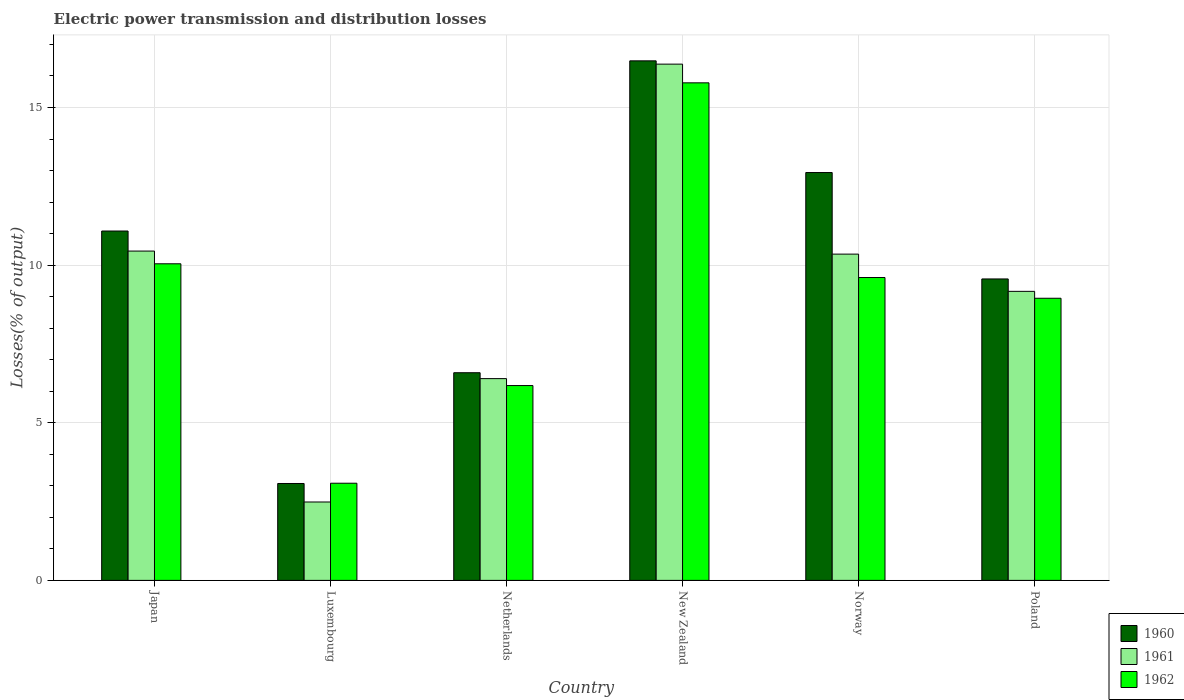How many different coloured bars are there?
Your answer should be compact. 3. How many groups of bars are there?
Your answer should be very brief. 6. Are the number of bars per tick equal to the number of legend labels?
Offer a very short reply. Yes. Are the number of bars on each tick of the X-axis equal?
Offer a terse response. Yes. How many bars are there on the 2nd tick from the left?
Provide a short and direct response. 3. How many bars are there on the 5th tick from the right?
Give a very brief answer. 3. What is the electric power transmission and distribution losses in 1962 in Norway?
Provide a short and direct response. 9.61. Across all countries, what is the maximum electric power transmission and distribution losses in 1960?
Offer a very short reply. 16.48. Across all countries, what is the minimum electric power transmission and distribution losses in 1962?
Give a very brief answer. 3.08. In which country was the electric power transmission and distribution losses in 1962 maximum?
Give a very brief answer. New Zealand. In which country was the electric power transmission and distribution losses in 1962 minimum?
Provide a succinct answer. Luxembourg. What is the total electric power transmission and distribution losses in 1960 in the graph?
Make the answer very short. 59.72. What is the difference between the electric power transmission and distribution losses in 1960 in New Zealand and that in Norway?
Keep it short and to the point. 3.54. What is the difference between the electric power transmission and distribution losses in 1960 in New Zealand and the electric power transmission and distribution losses in 1962 in Norway?
Provide a short and direct response. 6.87. What is the average electric power transmission and distribution losses in 1960 per country?
Make the answer very short. 9.95. What is the difference between the electric power transmission and distribution losses of/in 1960 and electric power transmission and distribution losses of/in 1961 in Netherlands?
Your answer should be very brief. 0.19. What is the ratio of the electric power transmission and distribution losses in 1962 in Japan to that in Poland?
Make the answer very short. 1.12. Is the difference between the electric power transmission and distribution losses in 1960 in Luxembourg and Netherlands greater than the difference between the electric power transmission and distribution losses in 1961 in Luxembourg and Netherlands?
Offer a terse response. Yes. What is the difference between the highest and the second highest electric power transmission and distribution losses in 1961?
Ensure brevity in your answer.  5.93. What is the difference between the highest and the lowest electric power transmission and distribution losses in 1962?
Your answer should be very brief. 12.7. Is the sum of the electric power transmission and distribution losses in 1962 in Japan and Luxembourg greater than the maximum electric power transmission and distribution losses in 1960 across all countries?
Provide a short and direct response. No. What does the 1st bar from the right in Netherlands represents?
Your answer should be compact. 1962. Is it the case that in every country, the sum of the electric power transmission and distribution losses in 1962 and electric power transmission and distribution losses in 1961 is greater than the electric power transmission and distribution losses in 1960?
Provide a succinct answer. Yes. How many bars are there?
Offer a very short reply. 18. How many countries are there in the graph?
Your answer should be very brief. 6. Are the values on the major ticks of Y-axis written in scientific E-notation?
Offer a very short reply. No. Does the graph contain any zero values?
Your answer should be very brief. No. Does the graph contain grids?
Give a very brief answer. Yes. How are the legend labels stacked?
Your response must be concise. Vertical. What is the title of the graph?
Make the answer very short. Electric power transmission and distribution losses. Does "2000" appear as one of the legend labels in the graph?
Provide a succinct answer. No. What is the label or title of the Y-axis?
Make the answer very short. Losses(% of output). What is the Losses(% of output) in 1960 in Japan?
Keep it short and to the point. 11.08. What is the Losses(% of output) in 1961 in Japan?
Make the answer very short. 10.45. What is the Losses(% of output) of 1962 in Japan?
Your response must be concise. 10.04. What is the Losses(% of output) of 1960 in Luxembourg?
Give a very brief answer. 3.07. What is the Losses(% of output) of 1961 in Luxembourg?
Your answer should be compact. 2.49. What is the Losses(% of output) in 1962 in Luxembourg?
Make the answer very short. 3.08. What is the Losses(% of output) in 1960 in Netherlands?
Ensure brevity in your answer.  6.59. What is the Losses(% of output) of 1961 in Netherlands?
Offer a terse response. 6.4. What is the Losses(% of output) of 1962 in Netherlands?
Offer a terse response. 6.18. What is the Losses(% of output) of 1960 in New Zealand?
Your response must be concise. 16.48. What is the Losses(% of output) of 1961 in New Zealand?
Your response must be concise. 16.38. What is the Losses(% of output) in 1962 in New Zealand?
Offer a very short reply. 15.78. What is the Losses(% of output) in 1960 in Norway?
Your answer should be compact. 12.94. What is the Losses(% of output) of 1961 in Norway?
Make the answer very short. 10.35. What is the Losses(% of output) in 1962 in Norway?
Make the answer very short. 9.61. What is the Losses(% of output) in 1960 in Poland?
Offer a terse response. 9.56. What is the Losses(% of output) of 1961 in Poland?
Your response must be concise. 9.17. What is the Losses(% of output) in 1962 in Poland?
Your answer should be very brief. 8.95. Across all countries, what is the maximum Losses(% of output) of 1960?
Provide a succinct answer. 16.48. Across all countries, what is the maximum Losses(% of output) of 1961?
Offer a very short reply. 16.38. Across all countries, what is the maximum Losses(% of output) in 1962?
Your answer should be compact. 15.78. Across all countries, what is the minimum Losses(% of output) in 1960?
Offer a very short reply. 3.07. Across all countries, what is the minimum Losses(% of output) of 1961?
Your answer should be very brief. 2.49. Across all countries, what is the minimum Losses(% of output) of 1962?
Your answer should be very brief. 3.08. What is the total Losses(% of output) of 1960 in the graph?
Your answer should be very brief. 59.72. What is the total Losses(% of output) in 1961 in the graph?
Your answer should be very brief. 55.23. What is the total Losses(% of output) in 1962 in the graph?
Your response must be concise. 53.65. What is the difference between the Losses(% of output) in 1960 in Japan and that in Luxembourg?
Ensure brevity in your answer.  8.01. What is the difference between the Losses(% of output) of 1961 in Japan and that in Luxembourg?
Your answer should be compact. 7.96. What is the difference between the Losses(% of output) of 1962 in Japan and that in Luxembourg?
Ensure brevity in your answer.  6.96. What is the difference between the Losses(% of output) of 1960 in Japan and that in Netherlands?
Ensure brevity in your answer.  4.49. What is the difference between the Losses(% of output) of 1961 in Japan and that in Netherlands?
Your response must be concise. 4.05. What is the difference between the Losses(% of output) of 1962 in Japan and that in Netherlands?
Your response must be concise. 3.86. What is the difference between the Losses(% of output) of 1960 in Japan and that in New Zealand?
Give a very brief answer. -5.4. What is the difference between the Losses(% of output) of 1961 in Japan and that in New Zealand?
Provide a short and direct response. -5.93. What is the difference between the Losses(% of output) of 1962 in Japan and that in New Zealand?
Offer a very short reply. -5.74. What is the difference between the Losses(% of output) in 1960 in Japan and that in Norway?
Provide a short and direct response. -1.85. What is the difference between the Losses(% of output) in 1961 in Japan and that in Norway?
Your answer should be very brief. 0.1. What is the difference between the Losses(% of output) of 1962 in Japan and that in Norway?
Your answer should be compact. 0.44. What is the difference between the Losses(% of output) of 1960 in Japan and that in Poland?
Offer a very short reply. 1.52. What is the difference between the Losses(% of output) of 1961 in Japan and that in Poland?
Ensure brevity in your answer.  1.28. What is the difference between the Losses(% of output) in 1962 in Japan and that in Poland?
Your answer should be very brief. 1.09. What is the difference between the Losses(% of output) of 1960 in Luxembourg and that in Netherlands?
Provide a succinct answer. -3.51. What is the difference between the Losses(% of output) in 1961 in Luxembourg and that in Netherlands?
Your response must be concise. -3.91. What is the difference between the Losses(% of output) of 1962 in Luxembourg and that in Netherlands?
Offer a very short reply. -3.1. What is the difference between the Losses(% of output) in 1960 in Luxembourg and that in New Zealand?
Your answer should be very brief. -13.41. What is the difference between the Losses(% of output) of 1961 in Luxembourg and that in New Zealand?
Your answer should be compact. -13.89. What is the difference between the Losses(% of output) of 1962 in Luxembourg and that in New Zealand?
Ensure brevity in your answer.  -12.7. What is the difference between the Losses(% of output) in 1960 in Luxembourg and that in Norway?
Offer a very short reply. -9.86. What is the difference between the Losses(% of output) of 1961 in Luxembourg and that in Norway?
Provide a succinct answer. -7.86. What is the difference between the Losses(% of output) of 1962 in Luxembourg and that in Norway?
Offer a very short reply. -6.53. What is the difference between the Losses(% of output) in 1960 in Luxembourg and that in Poland?
Your response must be concise. -6.49. What is the difference between the Losses(% of output) in 1961 in Luxembourg and that in Poland?
Your response must be concise. -6.68. What is the difference between the Losses(% of output) in 1962 in Luxembourg and that in Poland?
Keep it short and to the point. -5.87. What is the difference between the Losses(% of output) of 1960 in Netherlands and that in New Zealand?
Keep it short and to the point. -9.89. What is the difference between the Losses(% of output) of 1961 in Netherlands and that in New Zealand?
Keep it short and to the point. -9.98. What is the difference between the Losses(% of output) of 1962 in Netherlands and that in New Zealand?
Offer a terse response. -9.6. What is the difference between the Losses(% of output) of 1960 in Netherlands and that in Norway?
Offer a very short reply. -6.35. What is the difference between the Losses(% of output) in 1961 in Netherlands and that in Norway?
Offer a terse response. -3.95. What is the difference between the Losses(% of output) of 1962 in Netherlands and that in Norway?
Offer a very short reply. -3.43. What is the difference between the Losses(% of output) in 1960 in Netherlands and that in Poland?
Make the answer very short. -2.97. What is the difference between the Losses(% of output) in 1961 in Netherlands and that in Poland?
Ensure brevity in your answer.  -2.77. What is the difference between the Losses(% of output) in 1962 in Netherlands and that in Poland?
Provide a short and direct response. -2.77. What is the difference between the Losses(% of output) in 1960 in New Zealand and that in Norway?
Provide a succinct answer. 3.54. What is the difference between the Losses(% of output) of 1961 in New Zealand and that in Norway?
Offer a very short reply. 6.03. What is the difference between the Losses(% of output) in 1962 in New Zealand and that in Norway?
Offer a terse response. 6.18. What is the difference between the Losses(% of output) of 1960 in New Zealand and that in Poland?
Your response must be concise. 6.92. What is the difference between the Losses(% of output) of 1961 in New Zealand and that in Poland?
Provide a short and direct response. 7.21. What is the difference between the Losses(% of output) of 1962 in New Zealand and that in Poland?
Ensure brevity in your answer.  6.83. What is the difference between the Losses(% of output) of 1960 in Norway and that in Poland?
Ensure brevity in your answer.  3.38. What is the difference between the Losses(% of output) in 1961 in Norway and that in Poland?
Offer a terse response. 1.18. What is the difference between the Losses(% of output) in 1962 in Norway and that in Poland?
Your response must be concise. 0.66. What is the difference between the Losses(% of output) in 1960 in Japan and the Losses(% of output) in 1961 in Luxembourg?
Provide a succinct answer. 8.6. What is the difference between the Losses(% of output) in 1960 in Japan and the Losses(% of output) in 1962 in Luxembourg?
Offer a terse response. 8. What is the difference between the Losses(% of output) in 1961 in Japan and the Losses(% of output) in 1962 in Luxembourg?
Ensure brevity in your answer.  7.36. What is the difference between the Losses(% of output) of 1960 in Japan and the Losses(% of output) of 1961 in Netherlands?
Ensure brevity in your answer.  4.68. What is the difference between the Losses(% of output) of 1960 in Japan and the Losses(% of output) of 1962 in Netherlands?
Your answer should be compact. 4.9. What is the difference between the Losses(% of output) in 1961 in Japan and the Losses(% of output) in 1962 in Netherlands?
Your answer should be compact. 4.27. What is the difference between the Losses(% of output) of 1960 in Japan and the Losses(% of output) of 1961 in New Zealand?
Offer a very short reply. -5.29. What is the difference between the Losses(% of output) of 1960 in Japan and the Losses(% of output) of 1962 in New Zealand?
Keep it short and to the point. -4.7. What is the difference between the Losses(% of output) of 1961 in Japan and the Losses(% of output) of 1962 in New Zealand?
Provide a succinct answer. -5.34. What is the difference between the Losses(% of output) in 1960 in Japan and the Losses(% of output) in 1961 in Norway?
Your answer should be compact. 0.73. What is the difference between the Losses(% of output) of 1960 in Japan and the Losses(% of output) of 1962 in Norway?
Your response must be concise. 1.47. What is the difference between the Losses(% of output) of 1961 in Japan and the Losses(% of output) of 1962 in Norway?
Offer a terse response. 0.84. What is the difference between the Losses(% of output) in 1960 in Japan and the Losses(% of output) in 1961 in Poland?
Offer a terse response. 1.91. What is the difference between the Losses(% of output) of 1960 in Japan and the Losses(% of output) of 1962 in Poland?
Your answer should be very brief. 2.13. What is the difference between the Losses(% of output) of 1961 in Japan and the Losses(% of output) of 1962 in Poland?
Offer a very short reply. 1.5. What is the difference between the Losses(% of output) in 1960 in Luxembourg and the Losses(% of output) in 1961 in Netherlands?
Offer a very short reply. -3.33. What is the difference between the Losses(% of output) in 1960 in Luxembourg and the Losses(% of output) in 1962 in Netherlands?
Your response must be concise. -3.11. What is the difference between the Losses(% of output) of 1961 in Luxembourg and the Losses(% of output) of 1962 in Netherlands?
Ensure brevity in your answer.  -3.69. What is the difference between the Losses(% of output) of 1960 in Luxembourg and the Losses(% of output) of 1961 in New Zealand?
Make the answer very short. -13.3. What is the difference between the Losses(% of output) in 1960 in Luxembourg and the Losses(% of output) in 1962 in New Zealand?
Provide a succinct answer. -12.71. What is the difference between the Losses(% of output) in 1961 in Luxembourg and the Losses(% of output) in 1962 in New Zealand?
Ensure brevity in your answer.  -13.3. What is the difference between the Losses(% of output) of 1960 in Luxembourg and the Losses(% of output) of 1961 in Norway?
Provide a short and direct response. -7.28. What is the difference between the Losses(% of output) in 1960 in Luxembourg and the Losses(% of output) in 1962 in Norway?
Keep it short and to the point. -6.53. What is the difference between the Losses(% of output) of 1961 in Luxembourg and the Losses(% of output) of 1962 in Norway?
Your answer should be very brief. -7.12. What is the difference between the Losses(% of output) in 1960 in Luxembourg and the Losses(% of output) in 1961 in Poland?
Provide a succinct answer. -6.09. What is the difference between the Losses(% of output) of 1960 in Luxembourg and the Losses(% of output) of 1962 in Poland?
Your answer should be very brief. -5.88. What is the difference between the Losses(% of output) in 1961 in Luxembourg and the Losses(% of output) in 1962 in Poland?
Provide a short and direct response. -6.46. What is the difference between the Losses(% of output) in 1960 in Netherlands and the Losses(% of output) in 1961 in New Zealand?
Keep it short and to the point. -9.79. What is the difference between the Losses(% of output) of 1960 in Netherlands and the Losses(% of output) of 1962 in New Zealand?
Offer a terse response. -9.2. What is the difference between the Losses(% of output) of 1961 in Netherlands and the Losses(% of output) of 1962 in New Zealand?
Your answer should be compact. -9.38. What is the difference between the Losses(% of output) in 1960 in Netherlands and the Losses(% of output) in 1961 in Norway?
Your response must be concise. -3.76. What is the difference between the Losses(% of output) of 1960 in Netherlands and the Losses(% of output) of 1962 in Norway?
Keep it short and to the point. -3.02. What is the difference between the Losses(% of output) in 1961 in Netherlands and the Losses(% of output) in 1962 in Norway?
Your answer should be compact. -3.21. What is the difference between the Losses(% of output) of 1960 in Netherlands and the Losses(% of output) of 1961 in Poland?
Provide a succinct answer. -2.58. What is the difference between the Losses(% of output) in 1960 in Netherlands and the Losses(% of output) in 1962 in Poland?
Your response must be concise. -2.36. What is the difference between the Losses(% of output) in 1961 in Netherlands and the Losses(% of output) in 1962 in Poland?
Provide a short and direct response. -2.55. What is the difference between the Losses(% of output) in 1960 in New Zealand and the Losses(% of output) in 1961 in Norway?
Your answer should be compact. 6.13. What is the difference between the Losses(% of output) in 1960 in New Zealand and the Losses(% of output) in 1962 in Norway?
Keep it short and to the point. 6.87. What is the difference between the Losses(% of output) of 1961 in New Zealand and the Losses(% of output) of 1962 in Norway?
Make the answer very short. 6.77. What is the difference between the Losses(% of output) in 1960 in New Zealand and the Losses(% of output) in 1961 in Poland?
Provide a short and direct response. 7.31. What is the difference between the Losses(% of output) of 1960 in New Zealand and the Losses(% of output) of 1962 in Poland?
Your answer should be compact. 7.53. What is the difference between the Losses(% of output) of 1961 in New Zealand and the Losses(% of output) of 1962 in Poland?
Give a very brief answer. 7.43. What is the difference between the Losses(% of output) in 1960 in Norway and the Losses(% of output) in 1961 in Poland?
Give a very brief answer. 3.77. What is the difference between the Losses(% of output) of 1960 in Norway and the Losses(% of output) of 1962 in Poland?
Provide a short and direct response. 3.99. What is the difference between the Losses(% of output) in 1961 in Norway and the Losses(% of output) in 1962 in Poland?
Ensure brevity in your answer.  1.4. What is the average Losses(% of output) in 1960 per country?
Give a very brief answer. 9.95. What is the average Losses(% of output) in 1961 per country?
Your response must be concise. 9.2. What is the average Losses(% of output) in 1962 per country?
Give a very brief answer. 8.94. What is the difference between the Losses(% of output) in 1960 and Losses(% of output) in 1961 in Japan?
Ensure brevity in your answer.  0.64. What is the difference between the Losses(% of output) of 1960 and Losses(% of output) of 1962 in Japan?
Make the answer very short. 1.04. What is the difference between the Losses(% of output) in 1961 and Losses(% of output) in 1962 in Japan?
Offer a terse response. 0.4. What is the difference between the Losses(% of output) of 1960 and Losses(% of output) of 1961 in Luxembourg?
Offer a terse response. 0.59. What is the difference between the Losses(% of output) of 1960 and Losses(% of output) of 1962 in Luxembourg?
Keep it short and to the point. -0.01. What is the difference between the Losses(% of output) of 1961 and Losses(% of output) of 1962 in Luxembourg?
Your response must be concise. -0.6. What is the difference between the Losses(% of output) of 1960 and Losses(% of output) of 1961 in Netherlands?
Offer a terse response. 0.19. What is the difference between the Losses(% of output) in 1960 and Losses(% of output) in 1962 in Netherlands?
Provide a succinct answer. 0.41. What is the difference between the Losses(% of output) in 1961 and Losses(% of output) in 1962 in Netherlands?
Make the answer very short. 0.22. What is the difference between the Losses(% of output) of 1960 and Losses(% of output) of 1961 in New Zealand?
Provide a succinct answer. 0.1. What is the difference between the Losses(% of output) of 1960 and Losses(% of output) of 1962 in New Zealand?
Provide a short and direct response. 0.7. What is the difference between the Losses(% of output) in 1961 and Losses(% of output) in 1962 in New Zealand?
Your answer should be very brief. 0.59. What is the difference between the Losses(% of output) in 1960 and Losses(% of output) in 1961 in Norway?
Ensure brevity in your answer.  2.59. What is the difference between the Losses(% of output) of 1960 and Losses(% of output) of 1962 in Norway?
Offer a very short reply. 3.33. What is the difference between the Losses(% of output) of 1961 and Losses(% of output) of 1962 in Norway?
Provide a short and direct response. 0.74. What is the difference between the Losses(% of output) of 1960 and Losses(% of output) of 1961 in Poland?
Your answer should be very brief. 0.39. What is the difference between the Losses(% of output) of 1960 and Losses(% of output) of 1962 in Poland?
Offer a very short reply. 0.61. What is the difference between the Losses(% of output) of 1961 and Losses(% of output) of 1962 in Poland?
Your response must be concise. 0.22. What is the ratio of the Losses(% of output) in 1960 in Japan to that in Luxembourg?
Your response must be concise. 3.61. What is the ratio of the Losses(% of output) in 1961 in Japan to that in Luxembourg?
Offer a very short reply. 4.2. What is the ratio of the Losses(% of output) of 1962 in Japan to that in Luxembourg?
Ensure brevity in your answer.  3.26. What is the ratio of the Losses(% of output) in 1960 in Japan to that in Netherlands?
Ensure brevity in your answer.  1.68. What is the ratio of the Losses(% of output) of 1961 in Japan to that in Netherlands?
Give a very brief answer. 1.63. What is the ratio of the Losses(% of output) in 1962 in Japan to that in Netherlands?
Provide a succinct answer. 1.62. What is the ratio of the Losses(% of output) in 1960 in Japan to that in New Zealand?
Your answer should be compact. 0.67. What is the ratio of the Losses(% of output) in 1961 in Japan to that in New Zealand?
Keep it short and to the point. 0.64. What is the ratio of the Losses(% of output) in 1962 in Japan to that in New Zealand?
Your answer should be compact. 0.64. What is the ratio of the Losses(% of output) of 1960 in Japan to that in Norway?
Provide a succinct answer. 0.86. What is the ratio of the Losses(% of output) of 1961 in Japan to that in Norway?
Your answer should be very brief. 1.01. What is the ratio of the Losses(% of output) in 1962 in Japan to that in Norway?
Provide a short and direct response. 1.05. What is the ratio of the Losses(% of output) in 1960 in Japan to that in Poland?
Provide a succinct answer. 1.16. What is the ratio of the Losses(% of output) in 1961 in Japan to that in Poland?
Give a very brief answer. 1.14. What is the ratio of the Losses(% of output) of 1962 in Japan to that in Poland?
Make the answer very short. 1.12. What is the ratio of the Losses(% of output) in 1960 in Luxembourg to that in Netherlands?
Offer a terse response. 0.47. What is the ratio of the Losses(% of output) in 1961 in Luxembourg to that in Netherlands?
Ensure brevity in your answer.  0.39. What is the ratio of the Losses(% of output) of 1962 in Luxembourg to that in Netherlands?
Your response must be concise. 0.5. What is the ratio of the Losses(% of output) of 1960 in Luxembourg to that in New Zealand?
Your answer should be very brief. 0.19. What is the ratio of the Losses(% of output) in 1961 in Luxembourg to that in New Zealand?
Keep it short and to the point. 0.15. What is the ratio of the Losses(% of output) in 1962 in Luxembourg to that in New Zealand?
Offer a terse response. 0.2. What is the ratio of the Losses(% of output) in 1960 in Luxembourg to that in Norway?
Offer a terse response. 0.24. What is the ratio of the Losses(% of output) of 1961 in Luxembourg to that in Norway?
Make the answer very short. 0.24. What is the ratio of the Losses(% of output) in 1962 in Luxembourg to that in Norway?
Offer a terse response. 0.32. What is the ratio of the Losses(% of output) of 1960 in Luxembourg to that in Poland?
Make the answer very short. 0.32. What is the ratio of the Losses(% of output) in 1961 in Luxembourg to that in Poland?
Your answer should be very brief. 0.27. What is the ratio of the Losses(% of output) in 1962 in Luxembourg to that in Poland?
Your answer should be compact. 0.34. What is the ratio of the Losses(% of output) in 1960 in Netherlands to that in New Zealand?
Your answer should be very brief. 0.4. What is the ratio of the Losses(% of output) in 1961 in Netherlands to that in New Zealand?
Offer a very short reply. 0.39. What is the ratio of the Losses(% of output) in 1962 in Netherlands to that in New Zealand?
Ensure brevity in your answer.  0.39. What is the ratio of the Losses(% of output) of 1960 in Netherlands to that in Norway?
Provide a succinct answer. 0.51. What is the ratio of the Losses(% of output) in 1961 in Netherlands to that in Norway?
Offer a terse response. 0.62. What is the ratio of the Losses(% of output) of 1962 in Netherlands to that in Norway?
Offer a terse response. 0.64. What is the ratio of the Losses(% of output) of 1960 in Netherlands to that in Poland?
Provide a short and direct response. 0.69. What is the ratio of the Losses(% of output) in 1961 in Netherlands to that in Poland?
Ensure brevity in your answer.  0.7. What is the ratio of the Losses(% of output) in 1962 in Netherlands to that in Poland?
Provide a short and direct response. 0.69. What is the ratio of the Losses(% of output) in 1960 in New Zealand to that in Norway?
Provide a succinct answer. 1.27. What is the ratio of the Losses(% of output) of 1961 in New Zealand to that in Norway?
Give a very brief answer. 1.58. What is the ratio of the Losses(% of output) in 1962 in New Zealand to that in Norway?
Provide a short and direct response. 1.64. What is the ratio of the Losses(% of output) in 1960 in New Zealand to that in Poland?
Provide a succinct answer. 1.72. What is the ratio of the Losses(% of output) of 1961 in New Zealand to that in Poland?
Your response must be concise. 1.79. What is the ratio of the Losses(% of output) of 1962 in New Zealand to that in Poland?
Give a very brief answer. 1.76. What is the ratio of the Losses(% of output) in 1960 in Norway to that in Poland?
Give a very brief answer. 1.35. What is the ratio of the Losses(% of output) of 1961 in Norway to that in Poland?
Give a very brief answer. 1.13. What is the ratio of the Losses(% of output) in 1962 in Norway to that in Poland?
Give a very brief answer. 1.07. What is the difference between the highest and the second highest Losses(% of output) of 1960?
Offer a terse response. 3.54. What is the difference between the highest and the second highest Losses(% of output) in 1961?
Your response must be concise. 5.93. What is the difference between the highest and the second highest Losses(% of output) of 1962?
Your answer should be very brief. 5.74. What is the difference between the highest and the lowest Losses(% of output) of 1960?
Offer a very short reply. 13.41. What is the difference between the highest and the lowest Losses(% of output) of 1961?
Offer a terse response. 13.89. What is the difference between the highest and the lowest Losses(% of output) in 1962?
Your answer should be compact. 12.7. 